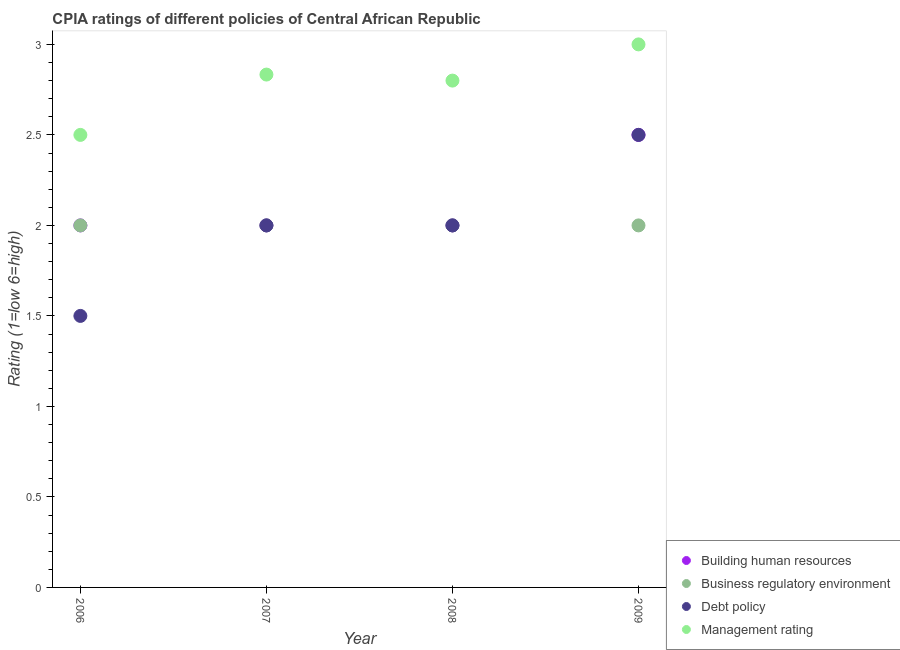How many different coloured dotlines are there?
Offer a very short reply. 4. What is the cpia rating of building human resources in 2009?
Your answer should be compact. 2.5. Across all years, what is the maximum cpia rating of management?
Your response must be concise. 3. What is the difference between the cpia rating of management in 2006 and that in 2009?
Ensure brevity in your answer.  -0.5. What is the average cpia rating of management per year?
Offer a terse response. 2.78. In the year 2008, what is the difference between the cpia rating of building human resources and cpia rating of management?
Provide a short and direct response. -0.8. What is the ratio of the cpia rating of management in 2007 to that in 2009?
Keep it short and to the point. 0.94. Is the cpia rating of debt policy in 2007 less than that in 2008?
Your answer should be very brief. No. Is the difference between the cpia rating of business regulatory environment in 2006 and 2007 greater than the difference between the cpia rating of debt policy in 2006 and 2007?
Your response must be concise. Yes. Is the sum of the cpia rating of debt policy in 2008 and 2009 greater than the maximum cpia rating of business regulatory environment across all years?
Provide a succinct answer. Yes. Is it the case that in every year, the sum of the cpia rating of management and cpia rating of business regulatory environment is greater than the sum of cpia rating of debt policy and cpia rating of building human resources?
Provide a succinct answer. Yes. Does the cpia rating of management monotonically increase over the years?
Offer a very short reply. No. Is the cpia rating of management strictly greater than the cpia rating of debt policy over the years?
Keep it short and to the point. Yes. How many dotlines are there?
Give a very brief answer. 4. How many years are there in the graph?
Keep it short and to the point. 4. How are the legend labels stacked?
Provide a succinct answer. Vertical. What is the title of the graph?
Your answer should be very brief. CPIA ratings of different policies of Central African Republic. Does "UNAIDS" appear as one of the legend labels in the graph?
Provide a succinct answer. No. What is the label or title of the X-axis?
Provide a short and direct response. Year. What is the Rating (1=low 6=high) of Debt policy in 2006?
Make the answer very short. 1.5. What is the Rating (1=low 6=high) of Management rating in 2006?
Keep it short and to the point. 2.5. What is the Rating (1=low 6=high) in Management rating in 2007?
Make the answer very short. 2.83. What is the Rating (1=low 6=high) in Business regulatory environment in 2008?
Keep it short and to the point. 2. What is the Rating (1=low 6=high) in Management rating in 2008?
Your answer should be compact. 2.8. What is the Rating (1=low 6=high) in Building human resources in 2009?
Offer a terse response. 2.5. Across all years, what is the maximum Rating (1=low 6=high) of Business regulatory environment?
Your answer should be compact. 2. Across all years, what is the maximum Rating (1=low 6=high) in Management rating?
Your answer should be very brief. 3. Across all years, what is the minimum Rating (1=low 6=high) in Building human resources?
Keep it short and to the point. 2. What is the total Rating (1=low 6=high) in Business regulatory environment in the graph?
Make the answer very short. 8. What is the total Rating (1=low 6=high) of Debt policy in the graph?
Ensure brevity in your answer.  8. What is the total Rating (1=low 6=high) of Management rating in the graph?
Provide a succinct answer. 11.13. What is the difference between the Rating (1=low 6=high) in Building human resources in 2006 and that in 2007?
Offer a very short reply. 0. What is the difference between the Rating (1=low 6=high) in Business regulatory environment in 2006 and that in 2007?
Give a very brief answer. 0. What is the difference between the Rating (1=low 6=high) of Building human resources in 2006 and that in 2008?
Offer a very short reply. 0. What is the difference between the Rating (1=low 6=high) in Business regulatory environment in 2006 and that in 2008?
Your response must be concise. 0. What is the difference between the Rating (1=low 6=high) in Management rating in 2006 and that in 2008?
Provide a succinct answer. -0.3. What is the difference between the Rating (1=low 6=high) in Business regulatory environment in 2006 and that in 2009?
Provide a succinct answer. 0. What is the difference between the Rating (1=low 6=high) in Management rating in 2006 and that in 2009?
Offer a very short reply. -0.5. What is the difference between the Rating (1=low 6=high) of Business regulatory environment in 2007 and that in 2008?
Provide a short and direct response. 0. What is the difference between the Rating (1=low 6=high) of Management rating in 2007 and that in 2008?
Your answer should be very brief. 0.03. What is the difference between the Rating (1=low 6=high) of Business regulatory environment in 2007 and that in 2009?
Offer a very short reply. 0. What is the difference between the Rating (1=low 6=high) of Debt policy in 2007 and that in 2009?
Offer a very short reply. -0.5. What is the difference between the Rating (1=low 6=high) in Business regulatory environment in 2008 and that in 2009?
Your response must be concise. 0. What is the difference between the Rating (1=low 6=high) in Debt policy in 2008 and that in 2009?
Give a very brief answer. -0.5. What is the difference between the Rating (1=low 6=high) in Management rating in 2008 and that in 2009?
Provide a short and direct response. -0.2. What is the difference between the Rating (1=low 6=high) of Building human resources in 2006 and the Rating (1=low 6=high) of Debt policy in 2007?
Your answer should be compact. 0. What is the difference between the Rating (1=low 6=high) in Building human resources in 2006 and the Rating (1=low 6=high) in Management rating in 2007?
Give a very brief answer. -0.83. What is the difference between the Rating (1=low 6=high) in Debt policy in 2006 and the Rating (1=low 6=high) in Management rating in 2007?
Ensure brevity in your answer.  -1.33. What is the difference between the Rating (1=low 6=high) in Building human resources in 2006 and the Rating (1=low 6=high) in Debt policy in 2009?
Keep it short and to the point. -0.5. What is the difference between the Rating (1=low 6=high) in Business regulatory environment in 2006 and the Rating (1=low 6=high) in Management rating in 2009?
Ensure brevity in your answer.  -1. What is the difference between the Rating (1=low 6=high) of Debt policy in 2006 and the Rating (1=low 6=high) of Management rating in 2009?
Make the answer very short. -1.5. What is the difference between the Rating (1=low 6=high) of Building human resources in 2007 and the Rating (1=low 6=high) of Business regulatory environment in 2008?
Give a very brief answer. 0. What is the difference between the Rating (1=low 6=high) of Business regulatory environment in 2007 and the Rating (1=low 6=high) of Debt policy in 2008?
Your answer should be compact. 0. What is the difference between the Rating (1=low 6=high) in Debt policy in 2007 and the Rating (1=low 6=high) in Management rating in 2008?
Offer a very short reply. -0.8. What is the difference between the Rating (1=low 6=high) of Building human resources in 2007 and the Rating (1=low 6=high) of Business regulatory environment in 2009?
Your answer should be compact. 0. What is the difference between the Rating (1=low 6=high) in Business regulatory environment in 2007 and the Rating (1=low 6=high) in Debt policy in 2009?
Keep it short and to the point. -0.5. What is the difference between the Rating (1=low 6=high) of Building human resources in 2008 and the Rating (1=low 6=high) of Business regulatory environment in 2009?
Provide a succinct answer. 0. What is the difference between the Rating (1=low 6=high) in Building human resources in 2008 and the Rating (1=low 6=high) in Debt policy in 2009?
Give a very brief answer. -0.5. What is the difference between the Rating (1=low 6=high) in Building human resources in 2008 and the Rating (1=low 6=high) in Management rating in 2009?
Your response must be concise. -1. What is the difference between the Rating (1=low 6=high) of Business regulatory environment in 2008 and the Rating (1=low 6=high) of Debt policy in 2009?
Your answer should be very brief. -0.5. What is the difference between the Rating (1=low 6=high) of Business regulatory environment in 2008 and the Rating (1=low 6=high) of Management rating in 2009?
Your response must be concise. -1. What is the difference between the Rating (1=low 6=high) of Debt policy in 2008 and the Rating (1=low 6=high) of Management rating in 2009?
Offer a terse response. -1. What is the average Rating (1=low 6=high) of Building human resources per year?
Ensure brevity in your answer.  2.12. What is the average Rating (1=low 6=high) of Business regulatory environment per year?
Your answer should be compact. 2. What is the average Rating (1=low 6=high) of Management rating per year?
Offer a terse response. 2.78. In the year 2006, what is the difference between the Rating (1=low 6=high) in Business regulatory environment and Rating (1=low 6=high) in Debt policy?
Make the answer very short. 0.5. In the year 2007, what is the difference between the Rating (1=low 6=high) in Building human resources and Rating (1=low 6=high) in Debt policy?
Your answer should be very brief. 0. In the year 2008, what is the difference between the Rating (1=low 6=high) of Building human resources and Rating (1=low 6=high) of Business regulatory environment?
Your response must be concise. 0. In the year 2008, what is the difference between the Rating (1=low 6=high) in Debt policy and Rating (1=low 6=high) in Management rating?
Offer a terse response. -0.8. In the year 2009, what is the difference between the Rating (1=low 6=high) in Building human resources and Rating (1=low 6=high) in Business regulatory environment?
Keep it short and to the point. 0.5. In the year 2009, what is the difference between the Rating (1=low 6=high) in Building human resources and Rating (1=low 6=high) in Management rating?
Your response must be concise. -0.5. In the year 2009, what is the difference between the Rating (1=low 6=high) in Debt policy and Rating (1=low 6=high) in Management rating?
Your answer should be very brief. -0.5. What is the ratio of the Rating (1=low 6=high) of Debt policy in 2006 to that in 2007?
Make the answer very short. 0.75. What is the ratio of the Rating (1=low 6=high) of Management rating in 2006 to that in 2007?
Offer a terse response. 0.88. What is the ratio of the Rating (1=low 6=high) in Building human resources in 2006 to that in 2008?
Your answer should be very brief. 1. What is the ratio of the Rating (1=low 6=high) of Debt policy in 2006 to that in 2008?
Give a very brief answer. 0.75. What is the ratio of the Rating (1=low 6=high) of Management rating in 2006 to that in 2008?
Your response must be concise. 0.89. What is the ratio of the Rating (1=low 6=high) in Debt policy in 2006 to that in 2009?
Ensure brevity in your answer.  0.6. What is the ratio of the Rating (1=low 6=high) in Building human resources in 2007 to that in 2008?
Your answer should be compact. 1. What is the ratio of the Rating (1=low 6=high) in Management rating in 2007 to that in 2008?
Offer a very short reply. 1.01. What is the ratio of the Rating (1=low 6=high) in Building human resources in 2007 to that in 2009?
Offer a very short reply. 0.8. What is the ratio of the Rating (1=low 6=high) of Management rating in 2007 to that in 2009?
Provide a short and direct response. 0.94. What is the ratio of the Rating (1=low 6=high) in Business regulatory environment in 2008 to that in 2009?
Your answer should be compact. 1. What is the ratio of the Rating (1=low 6=high) in Debt policy in 2008 to that in 2009?
Your response must be concise. 0.8. What is the difference between the highest and the second highest Rating (1=low 6=high) of Building human resources?
Provide a short and direct response. 0.5. What is the difference between the highest and the second highest Rating (1=low 6=high) of Debt policy?
Your answer should be very brief. 0.5. What is the difference between the highest and the second highest Rating (1=low 6=high) of Management rating?
Make the answer very short. 0.17. What is the difference between the highest and the lowest Rating (1=low 6=high) in Business regulatory environment?
Give a very brief answer. 0. What is the difference between the highest and the lowest Rating (1=low 6=high) in Management rating?
Offer a very short reply. 0.5. 